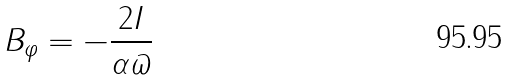Convert formula to latex. <formula><loc_0><loc_0><loc_500><loc_500>B _ { \varphi } = - \frac { 2 I } { \alpha \varpi }</formula> 